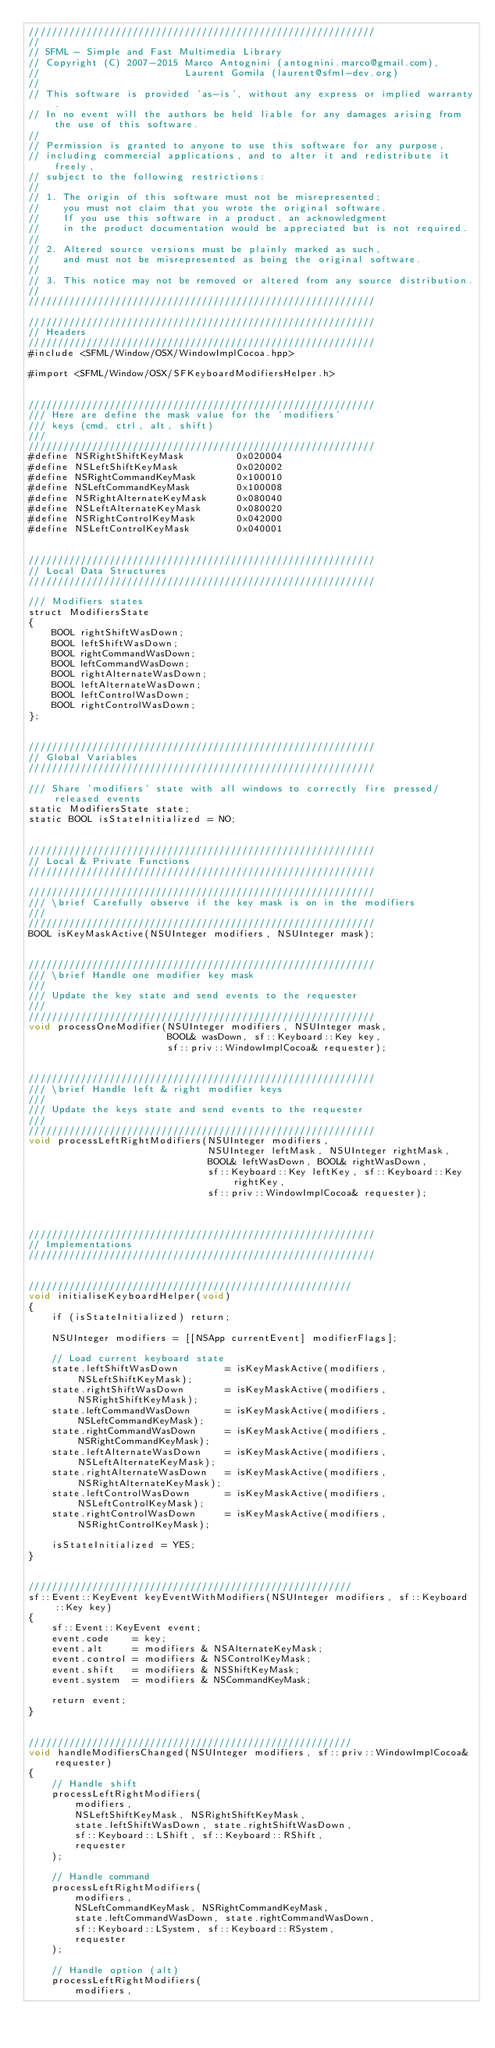Convert code to text. <code><loc_0><loc_0><loc_500><loc_500><_ObjectiveC_>////////////////////////////////////////////////////////////
//
// SFML - Simple and Fast Multimedia Library
// Copyright (C) 2007-2015 Marco Antognini (antognini.marco@gmail.com),
//                         Laurent Gomila (laurent@sfml-dev.org)
//
// This software is provided 'as-is', without any express or implied warranty.
// In no event will the authors be held liable for any damages arising from the use of this software.
//
// Permission is granted to anyone to use this software for any purpose,
// including commercial applications, and to alter it and redistribute it freely,
// subject to the following restrictions:
//
// 1. The origin of this software must not be misrepresented;
//    you must not claim that you wrote the original software.
//    If you use this software in a product, an acknowledgment
//    in the product documentation would be appreciated but is not required.
//
// 2. Altered source versions must be plainly marked as such,
//    and must not be misrepresented as being the original software.
//
// 3. This notice may not be removed or altered from any source distribution.
//
////////////////////////////////////////////////////////////

////////////////////////////////////////////////////////////
// Headers
////////////////////////////////////////////////////////////
#include <SFML/Window/OSX/WindowImplCocoa.hpp>

#import <SFML/Window/OSX/SFKeyboardModifiersHelper.h>


////////////////////////////////////////////////////////////
/// Here are define the mask value for the 'modifiers'
/// keys (cmd, ctrl, alt, shift)
///
////////////////////////////////////////////////////////////
#define NSRightShiftKeyMask         0x020004
#define NSLeftShiftKeyMask          0x020002
#define NSRightCommandKeyMask       0x100010
#define NSLeftCommandKeyMask        0x100008
#define NSRightAlternateKeyMask     0x080040
#define NSLeftAlternateKeyMask      0x080020
#define NSRightControlKeyMask       0x042000
#define NSLeftControlKeyMask        0x040001


////////////////////////////////////////////////////////////
// Local Data Structures
////////////////////////////////////////////////////////////

/// Modifiers states
struct ModifiersState
{
    BOOL rightShiftWasDown;
    BOOL leftShiftWasDown;
    BOOL rightCommandWasDown;
    BOOL leftCommandWasDown;
    BOOL rightAlternateWasDown;
    BOOL leftAlternateWasDown;
    BOOL leftControlWasDown;
    BOOL rightControlWasDown;
};


////////////////////////////////////////////////////////////
// Global Variables
////////////////////////////////////////////////////////////

/// Share 'modifiers' state with all windows to correctly fire pressed/released events
static ModifiersState state;
static BOOL isStateInitialized = NO;


////////////////////////////////////////////////////////////
// Local & Private Functions
////////////////////////////////////////////////////////////

////////////////////////////////////////////////////////////
/// \brief Carefully observe if the key mask is on in the modifiers
///
////////////////////////////////////////////////////////////
BOOL isKeyMaskActive(NSUInteger modifiers, NSUInteger mask);


////////////////////////////////////////////////////////////
/// \brief Handle one modifier key mask
///
/// Update the key state and send events to the requester
///
////////////////////////////////////////////////////////////
void processOneModifier(NSUInteger modifiers, NSUInteger mask,
                        BOOL& wasDown, sf::Keyboard::Key key,
                        sf::priv::WindowImplCocoa& requester);


////////////////////////////////////////////////////////////
/// \brief Handle left & right modifier keys
///
/// Update the keys state and send events to the requester
///
////////////////////////////////////////////////////////////
void processLeftRightModifiers(NSUInteger modifiers,
                               NSUInteger leftMask, NSUInteger rightMask,
                               BOOL& leftWasDown, BOOL& rightWasDown,
                               sf::Keyboard::Key leftKey, sf::Keyboard::Key rightKey,
                               sf::priv::WindowImplCocoa& requester);



////////////////////////////////////////////////////////////
// Implementations
////////////////////////////////////////////////////////////


////////////////////////////////////////////////////////
void initialiseKeyboardHelper(void)
{
    if (isStateInitialized) return;

    NSUInteger modifiers = [[NSApp currentEvent] modifierFlags];

    // Load current keyboard state
    state.leftShiftWasDown        = isKeyMaskActive(modifiers, NSLeftShiftKeyMask);
    state.rightShiftWasDown       = isKeyMaskActive(modifiers, NSRightShiftKeyMask);
    state.leftCommandWasDown      = isKeyMaskActive(modifiers, NSLeftCommandKeyMask);
    state.rightCommandWasDown     = isKeyMaskActive(modifiers, NSRightCommandKeyMask);
    state.leftAlternateWasDown    = isKeyMaskActive(modifiers, NSLeftAlternateKeyMask);
    state.rightAlternateWasDown   = isKeyMaskActive(modifiers, NSRightAlternateKeyMask);
    state.leftControlWasDown      = isKeyMaskActive(modifiers, NSLeftControlKeyMask);
    state.rightControlWasDown     = isKeyMaskActive(modifiers, NSRightControlKeyMask);

    isStateInitialized = YES;
}


////////////////////////////////////////////////////////
sf::Event::KeyEvent keyEventWithModifiers(NSUInteger modifiers, sf::Keyboard::Key key)
{
    sf::Event::KeyEvent event;
    event.code    = key;
    event.alt     = modifiers & NSAlternateKeyMask;
    event.control = modifiers & NSControlKeyMask;
    event.shift   = modifiers & NSShiftKeyMask;
    event.system  = modifiers & NSCommandKeyMask;

    return event;
}


////////////////////////////////////////////////////////
void handleModifiersChanged(NSUInteger modifiers, sf::priv::WindowImplCocoa& requester)
{
    // Handle shift
    processLeftRightModifiers(
        modifiers,
        NSLeftShiftKeyMask, NSRightShiftKeyMask,
        state.leftShiftWasDown, state.rightShiftWasDown,
        sf::Keyboard::LShift, sf::Keyboard::RShift,
        requester
    );

    // Handle command
    processLeftRightModifiers(
        modifiers,
        NSLeftCommandKeyMask, NSRightCommandKeyMask,
        state.leftCommandWasDown, state.rightCommandWasDown,
        sf::Keyboard::LSystem, sf::Keyboard::RSystem,
        requester
    );

    // Handle option (alt)
    processLeftRightModifiers(
        modifiers,</code> 